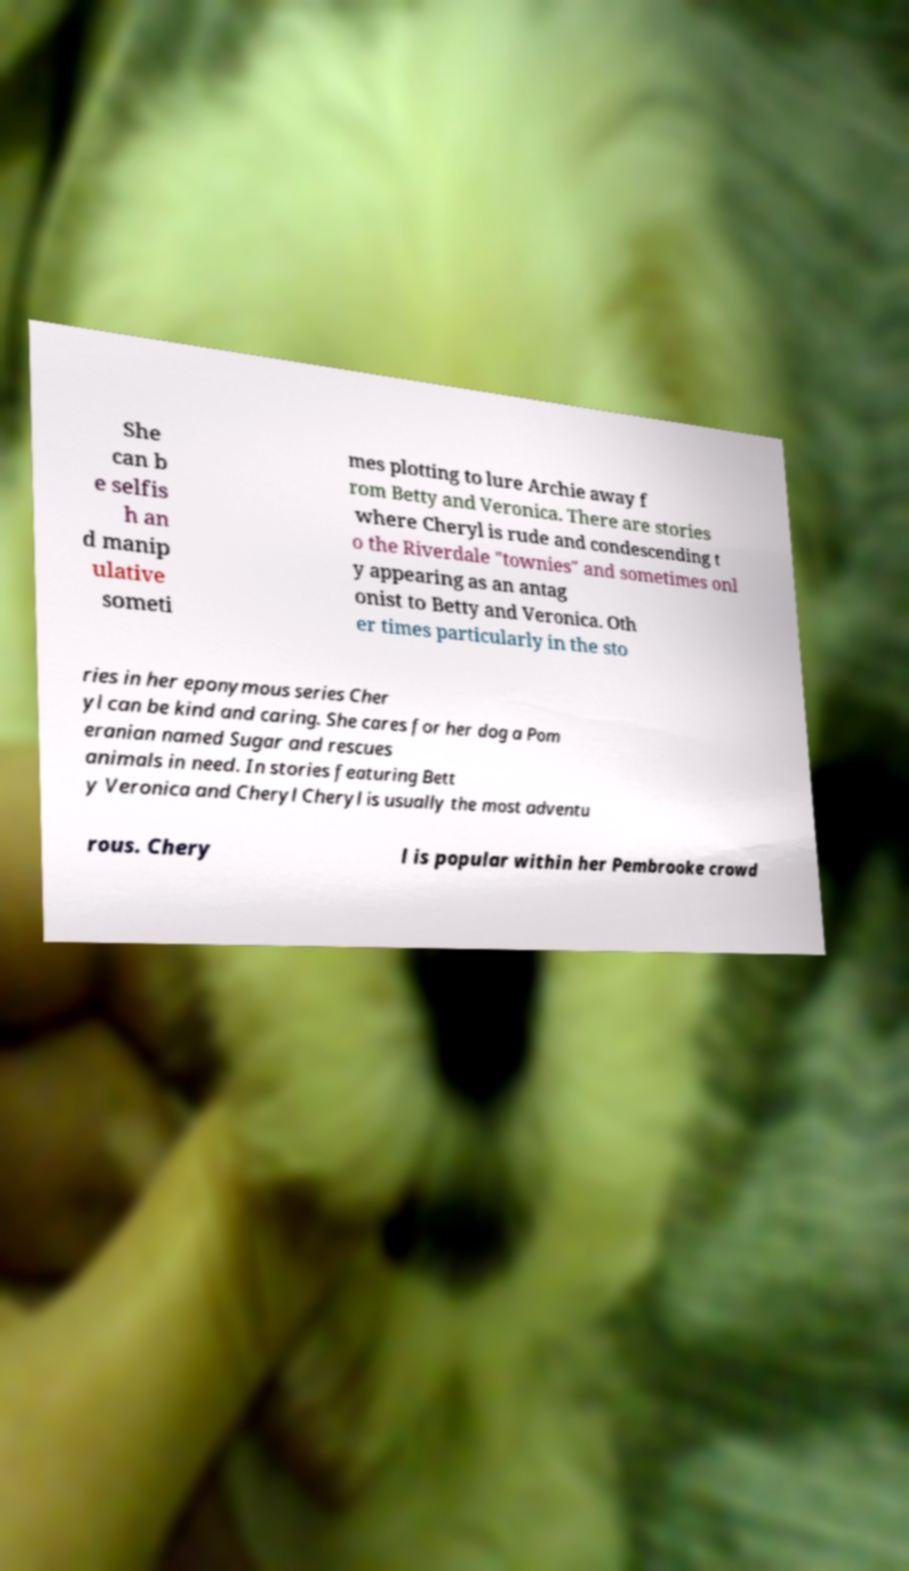I need the written content from this picture converted into text. Can you do that? She can b e selfis h an d manip ulative someti mes plotting to lure Archie away f rom Betty and Veronica. There are stories where Cheryl is rude and condescending t o the Riverdale "townies" and sometimes onl y appearing as an antag onist to Betty and Veronica. Oth er times particularly in the sto ries in her eponymous series Cher yl can be kind and caring. She cares for her dog a Pom eranian named Sugar and rescues animals in need. In stories featuring Bett y Veronica and Cheryl Cheryl is usually the most adventu rous. Chery l is popular within her Pembrooke crowd 